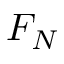<formula> <loc_0><loc_0><loc_500><loc_500>F _ { N }</formula> 